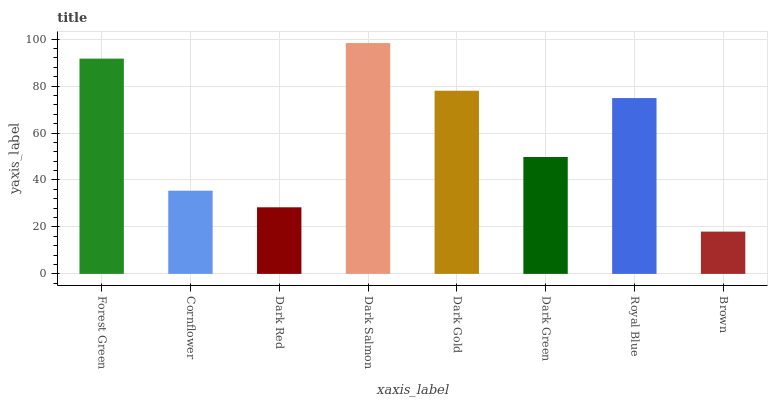Is Cornflower the minimum?
Answer yes or no. No. Is Cornflower the maximum?
Answer yes or no. No. Is Forest Green greater than Cornflower?
Answer yes or no. Yes. Is Cornflower less than Forest Green?
Answer yes or no. Yes. Is Cornflower greater than Forest Green?
Answer yes or no. No. Is Forest Green less than Cornflower?
Answer yes or no. No. Is Royal Blue the high median?
Answer yes or no. Yes. Is Dark Green the low median?
Answer yes or no. Yes. Is Dark Gold the high median?
Answer yes or no. No. Is Royal Blue the low median?
Answer yes or no. No. 